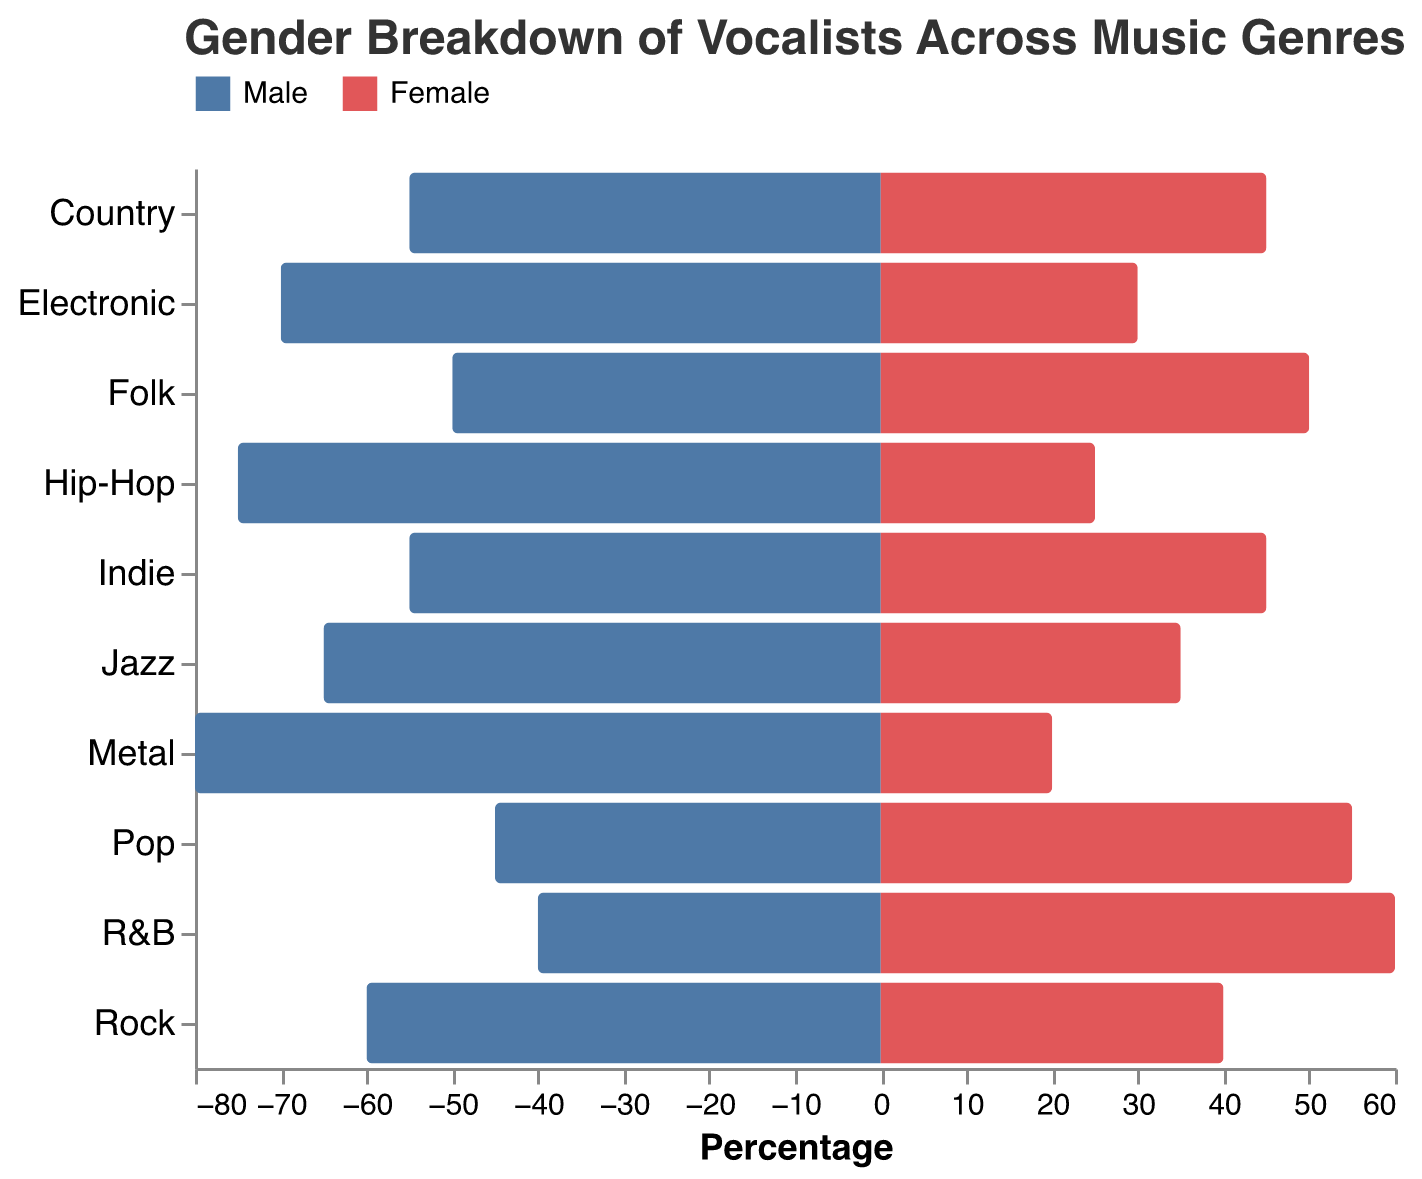What is the title of the figure? The title of the figure is located at the top and typically describes the content of the chart. In this case, the title reads "Gender Breakdown of Vocalists Across Music Genres".
Answer: Gender Breakdown of Vocalists Across Music Genres Which genre has an equal percentage of male and female vocalists? Look for the genre where the percentages of male and female vocalists are the same along the horizontal axis. Folk shows 50% male and 50% female.
Answer: Folk Is Pop dominated more by male or female vocalists? Check the segment of the bar for Pop. The female vocalists' portion extends more on the positive side (right), indicating a higher percentage (55% female vs. 45% male).
Answer: Female What genre has the highest percentage of male vocalists? Observe the bars that extend the furthest to the left, indicating the highest percentage of male vocalists. Metal has the furthest left bar at 80%.
Answer: Metal Which genre has the lowest percentage of female vocalists? Look for the genre with the smallest rightward extending bar. This is Metal, with only 20% female vocalists.
Answer: Metal How does the percentage of male vocalists in Jazz compare to that in Pop? Compare the left-extending bars for Jazz and Pop. Jazz has 65% male vocalists, while Pop has 45%. Therefore, Jazz has a higher percentage.
Answer: Jazz has more male vocalists than Pop What is the total percentage of male and female vocalists in Country and Indie combined? For each genre, sum the percentages of male and female vocalists. Both Country and Indie have 55% male and 45% female each. Adding these gives 110% male and 90% female (55+55 male, 45+45 female).
Answer: 110% male, 90% female In which genres do males occupy more than 70 per cent of the vocalists? Look for bars where the leftward extending portion is more than 70%. You will find Electronic, Metal, and Hip-Hop fall into this category.
Answer: Electronic, Metal, Hip-Hop Which genres show a significant dominance of female vocalists? Check where the positive side (right extending bars) are substantially longer than the negative side (left extending bars). Pop and R&B show a notable dominance with 55% and 60% female vocalists respectively.
Answer: Pop, R&B 